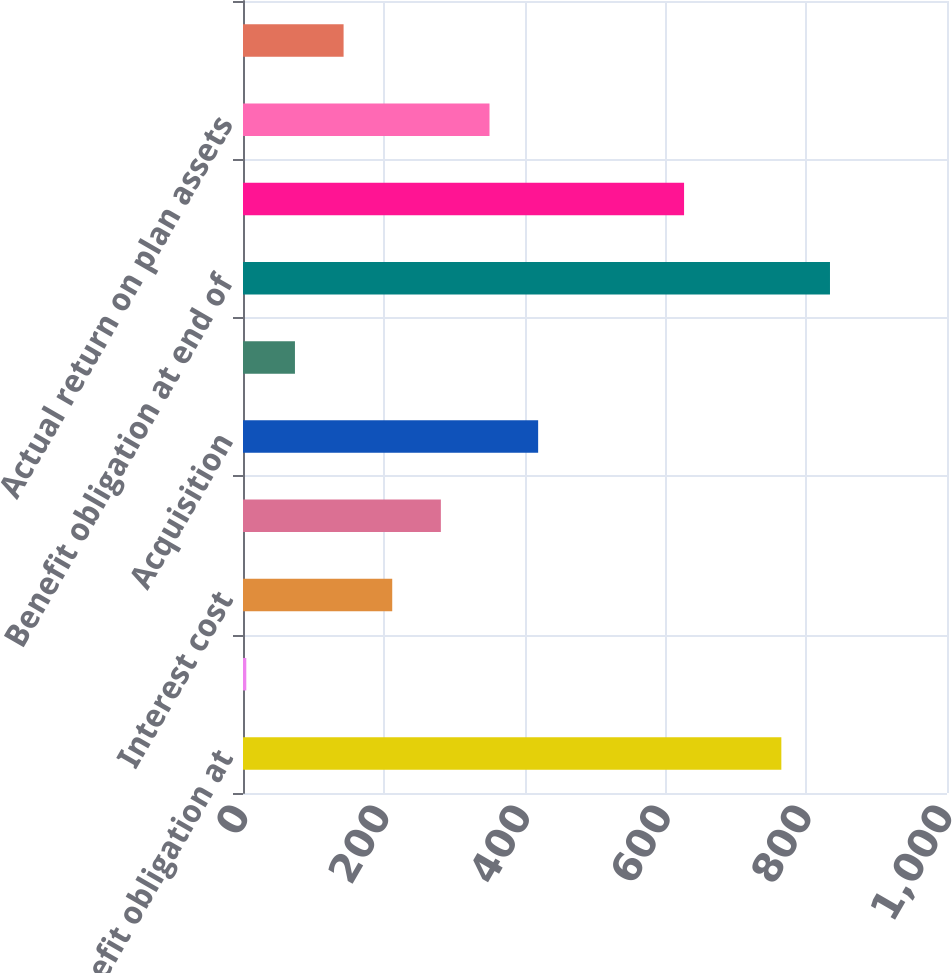Convert chart to OTSL. <chart><loc_0><loc_0><loc_500><loc_500><bar_chart><fcel>Benefit obligation at<fcel>Service cost<fcel>Interest cost<fcel>Benefits paid and other<fcel>Acquisition<fcel>Actuarial loss (gain)<fcel>Benefit obligation at end of<fcel>Fair value of plan assets at<fcel>Actual return on plan assets<fcel>Employer contributions<nl><fcel>764.69<fcel>4.7<fcel>211.97<fcel>281.06<fcel>419.24<fcel>73.79<fcel>833.78<fcel>626.51<fcel>350.15<fcel>142.88<nl></chart> 